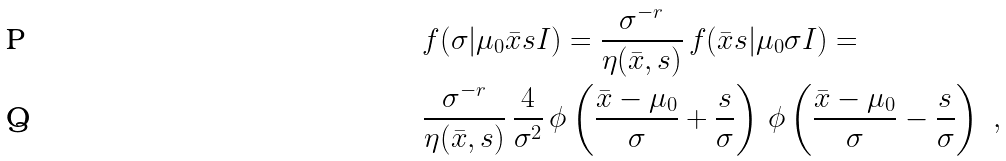<formula> <loc_0><loc_0><loc_500><loc_500>& f ( \sigma | \mu _ { 0 } \bar { x } s I ) = \frac { \sigma ^ { - r } } { \eta ( \bar { x } , s ) } \, f ( \bar { x } s | \mu _ { 0 } \sigma I ) = \\ & \frac { \sigma ^ { - r } } { \eta ( \bar { x } , s ) } \, \frac { 4 } { \sigma ^ { 2 } } \, \phi \left ( \frac { \bar { x } - \mu _ { 0 } } { \sigma } + \frac { s } { \sigma } \right ) \, \phi \left ( \frac { \bar { x } - \mu _ { 0 } } { \sigma } - \frac { s } { \sigma } \right ) \ ,</formula> 